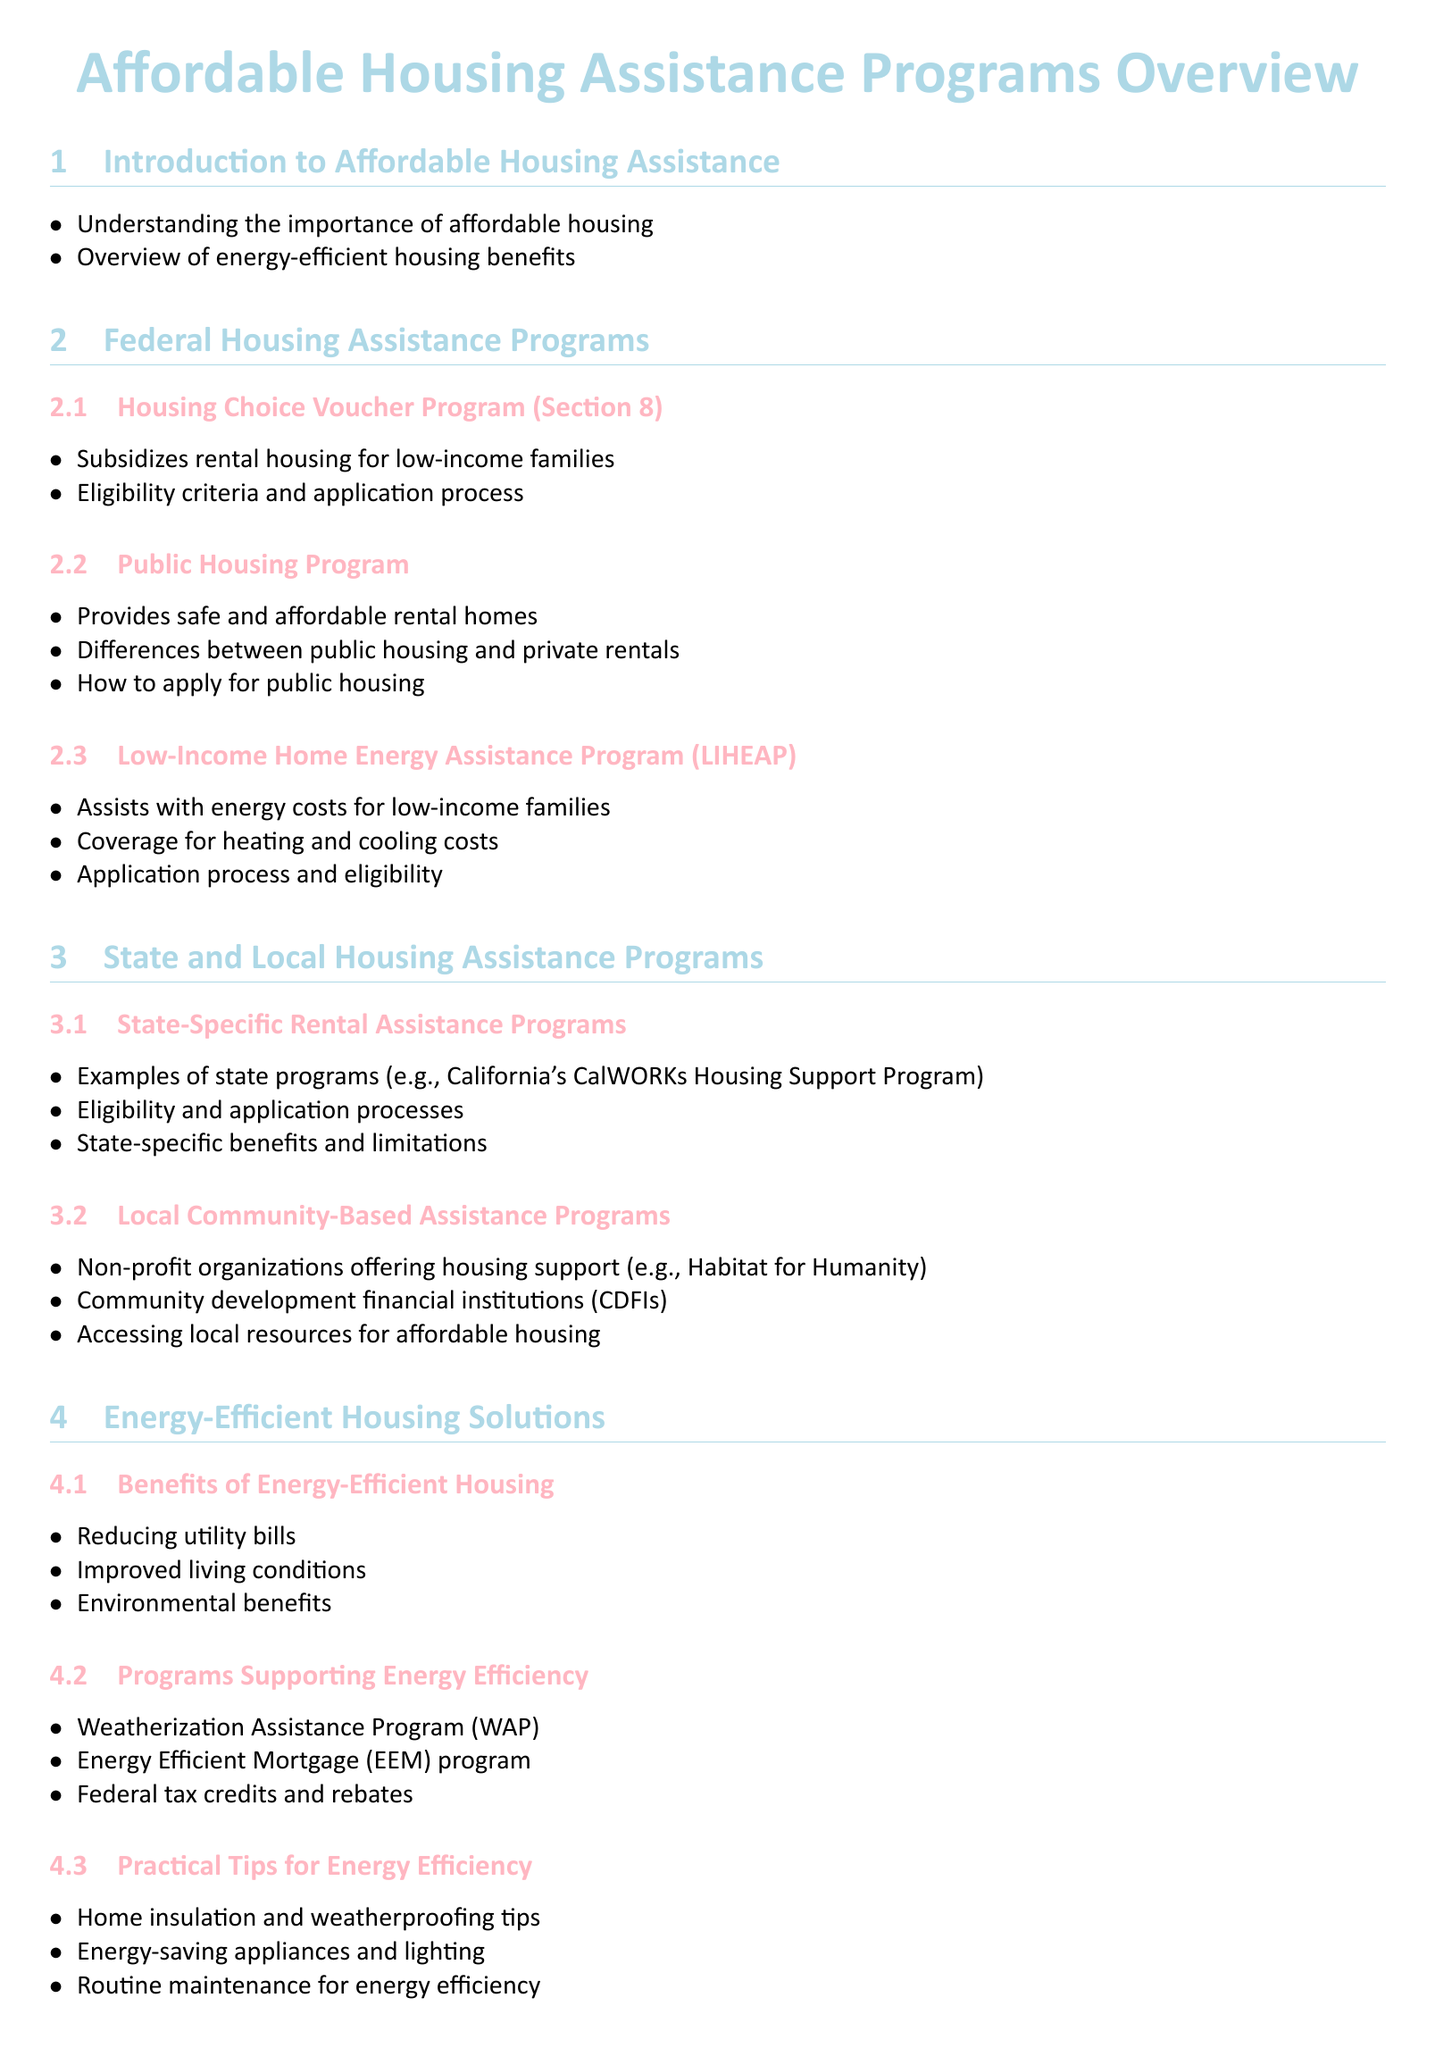What is the Housing Choice Voucher Program also known as? The document refers to it as Section 8.
Answer: Section 8 What kind of assistance does LIHEAP provide? LIHEAP assists with energy costs for low-income families.
Answer: Energy costs Which organization is an example of a local community-based assistance program? The document mentions Habitat for Humanity as an example.
Answer: Habitat for Humanity What is one benefit of energy-efficient housing? The document states that it helps in reducing utility bills.
Answer: Reducing utility bills What type of assistance is the Weatherization Assistance Program? The document lists it under programs supporting energy efficiency.
Answer: Energy efficiency What should one gather before applying for housing assistance? The document advises gathering necessary documentation before applying.
Answer: Necessary documentation 